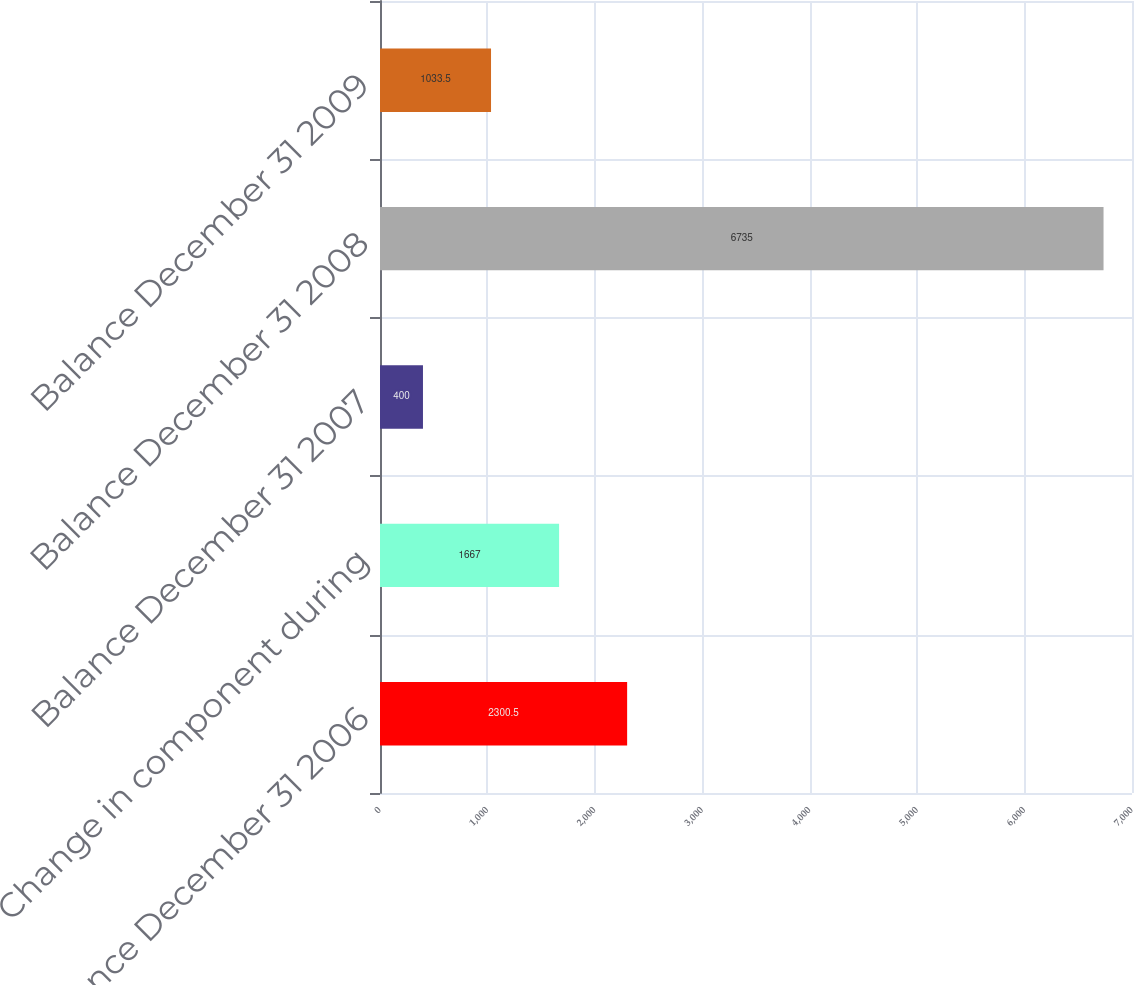Convert chart to OTSL. <chart><loc_0><loc_0><loc_500><loc_500><bar_chart><fcel>Balance December 31 2006<fcel>Change in component during<fcel>Balance December 31 2007<fcel>Balance December 31 2008<fcel>Balance December 31 2009<nl><fcel>2300.5<fcel>1667<fcel>400<fcel>6735<fcel>1033.5<nl></chart> 